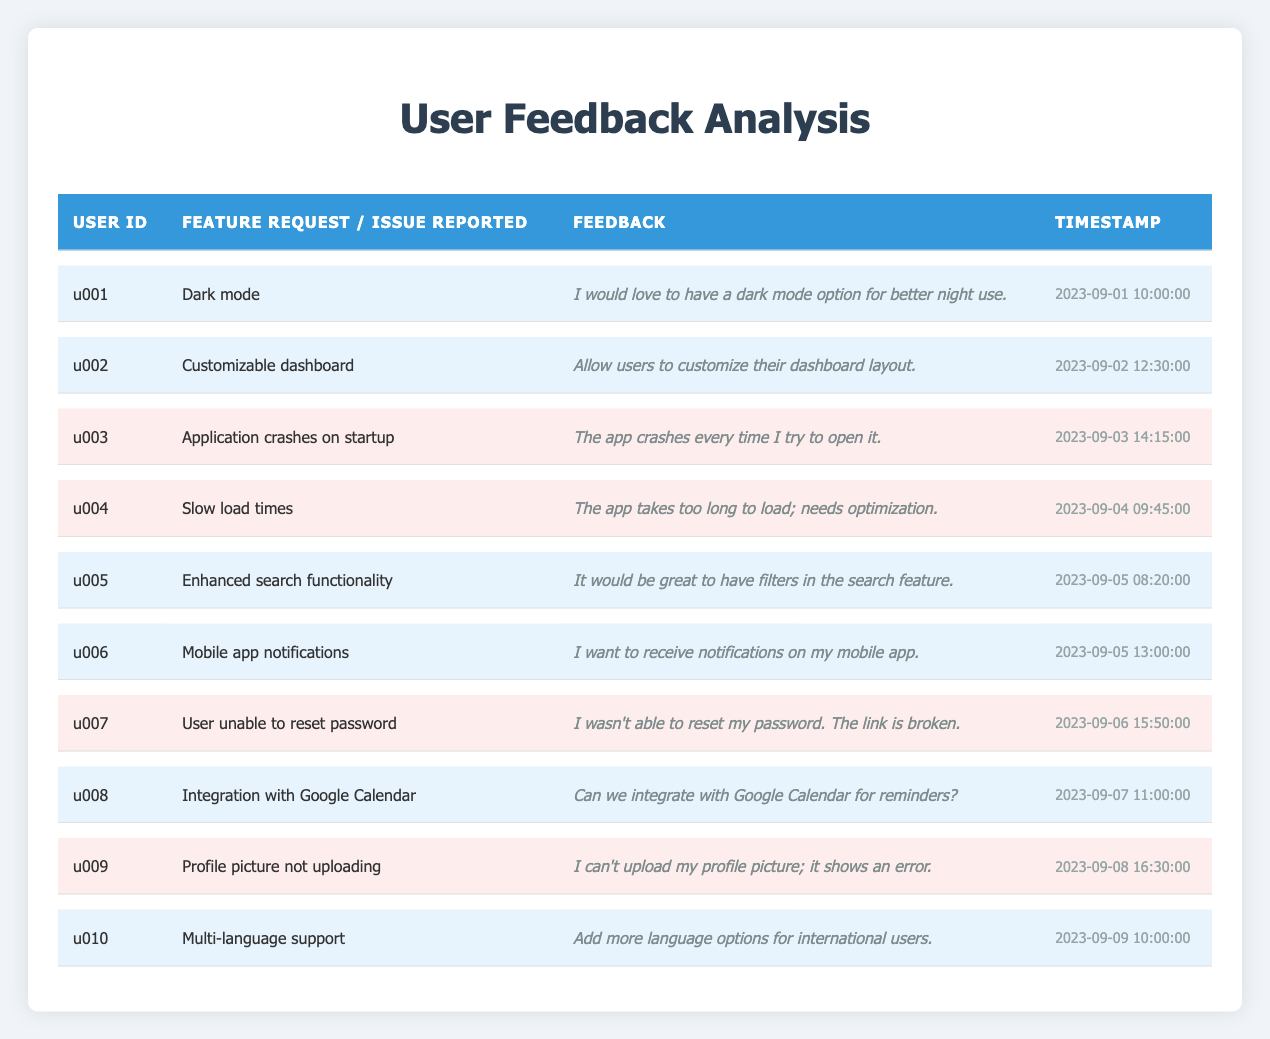What feature has the most requests according to the table? By reviewing the table, I can see that "Dark mode," "Customizable dashboard," "Enhanced search functionality," "Mobile app notifications," "Integration with Google Calendar," and "Multi-language support" are all feature requests. Each of these appears once, indicating that they are tied in the number of requests.
Answer: Dark mode, Customizable dashboard, Enhanced search functionality, Mobile app notifications, Integration with Google Calendar, Multi-language support How many issues were reported in total? The table lists several user issues. Each specific issue is represented in a row where the "issue_reported" column is filled. Counting these rows shows there are 5 reported issues.
Answer: 5 Is there a request for a feature related to notifications? The table lists a feature request for "Mobile app notifications," showing that a user wants this capability. Thus, the answer is yes.
Answer: Yes Which feedback was given earliest in time? By reviewing the timestamps for each feedback entry, the earliest timestamp is "2023-09-01T10:00:00Z," corresponding to the feedback for "Dark mode."
Answer: Dark mode Were there more feature requests or reported issues? There are 5 feature requests (rows related to feature requests) and 5 reported issues (rows related to issues). Since both counts are equal, the answer is that neither is greater.
Answer: Neither What percentage of total feedback entries are feature requests? The total number of feedback entries is 10, out of which 5 are feature requests. Therefore, the percentage is (5/10) * 100 = 50%.
Answer: 50% Which issue reported the earliest? By examining the timestamps for issues, "Application crashes on startup" at "2023-09-03T14:15:00Z" is the earliest issue reported in the table.
Answer: Application crashes on startup How many users reported an issue with app functionality? Counting the rows in the table where "issue_reported" is filled indicates that 5 users reported issues related to app functionality.
Answer: 5 Is there a user feedback entry for a feature request on dashboard customization? Yes, the table shows that user "u002" requested "Customizable dashboard," directly indicating this is a feature request.
Answer: Yes How many total unique users submitted feedback on feature requests? There are 6 unique users who made feature requests (u001, u002, u005, u006, u008, and u010), which can be determined from their respective entries.
Answer: 6 